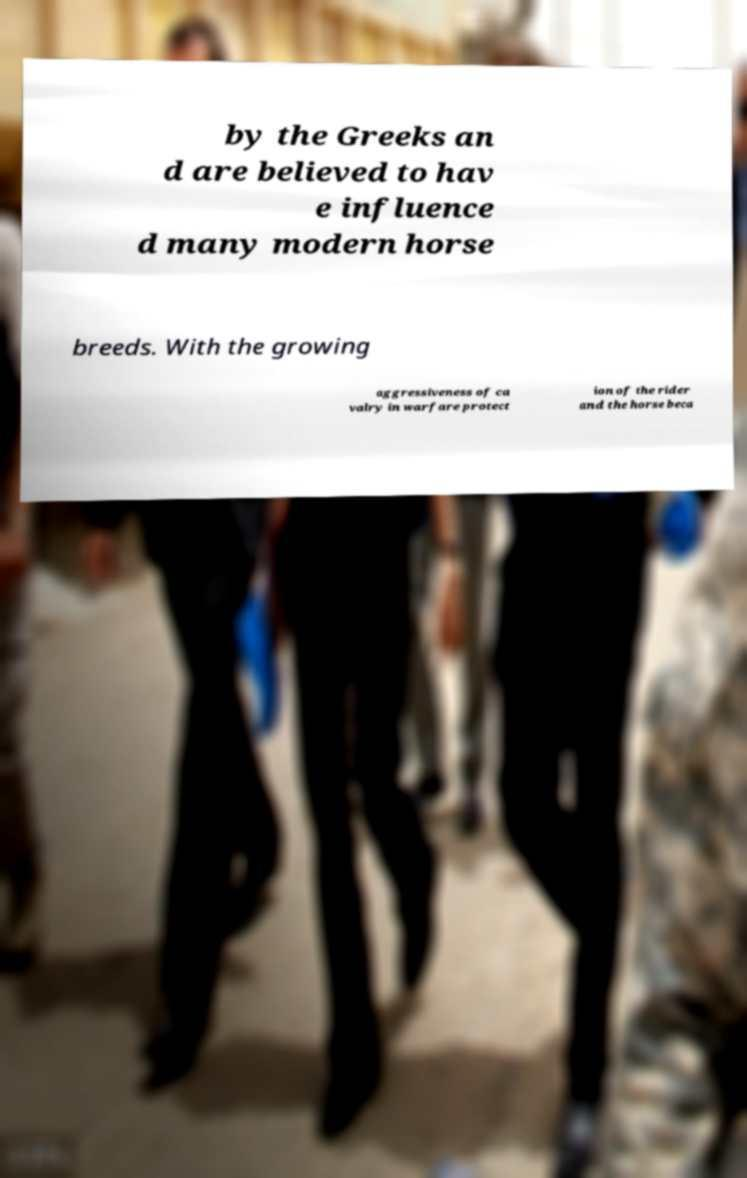What messages or text are displayed in this image? I need them in a readable, typed format. by the Greeks an d are believed to hav e influence d many modern horse breeds. With the growing aggressiveness of ca valry in warfare protect ion of the rider and the horse beca 